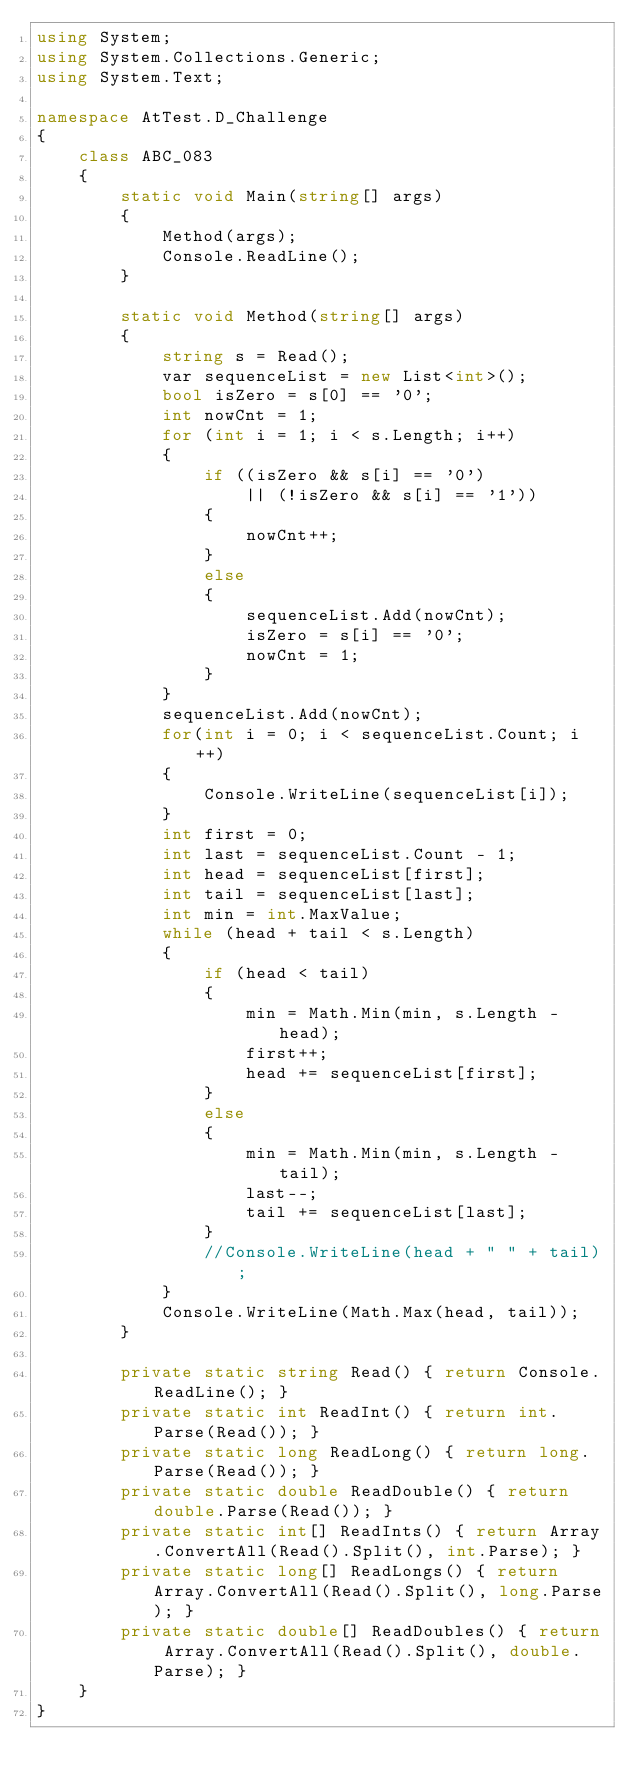<code> <loc_0><loc_0><loc_500><loc_500><_C#_>using System;
using System.Collections.Generic;
using System.Text;

namespace AtTest.D_Challenge
{
    class ABC_083
    {
        static void Main(string[] args)
        {
            Method(args);
            Console.ReadLine();
        }

        static void Method(string[] args)
        {
            string s = Read();
            var sequenceList = new List<int>();
            bool isZero = s[0] == '0';
            int nowCnt = 1;
            for (int i = 1; i < s.Length; i++)
            {
                if ((isZero && s[i] == '0')
                    || (!isZero && s[i] == '1'))
                {
                    nowCnt++;
                }
                else
                {
                    sequenceList.Add(nowCnt);
                    isZero = s[i] == '0';
                    nowCnt = 1;
                }
            }
            sequenceList.Add(nowCnt);
            for(int i = 0; i < sequenceList.Count; i++)
            {
                Console.WriteLine(sequenceList[i]);
            }
            int first = 0;
            int last = sequenceList.Count - 1;
            int head = sequenceList[first];
            int tail = sequenceList[last];
            int min = int.MaxValue;
            while (head + tail < s.Length)
            {
                if (head < tail)
                {
                    min = Math.Min(min, s.Length - head);
                    first++;
                    head += sequenceList[first];
                }
                else
                {
                    min = Math.Min(min, s.Length - tail);
                    last--;
                    tail += sequenceList[last];
                }
                //Console.WriteLine(head + " " + tail);
            }
            Console.WriteLine(Math.Max(head, tail));
        }

        private static string Read() { return Console.ReadLine(); }
        private static int ReadInt() { return int.Parse(Read()); }
        private static long ReadLong() { return long.Parse(Read()); }
        private static double ReadDouble() { return double.Parse(Read()); }
        private static int[] ReadInts() { return Array.ConvertAll(Read().Split(), int.Parse); }
        private static long[] ReadLongs() { return Array.ConvertAll(Read().Split(), long.Parse); }
        private static double[] ReadDoubles() { return Array.ConvertAll(Read().Split(), double.Parse); }
    }
}
</code> 